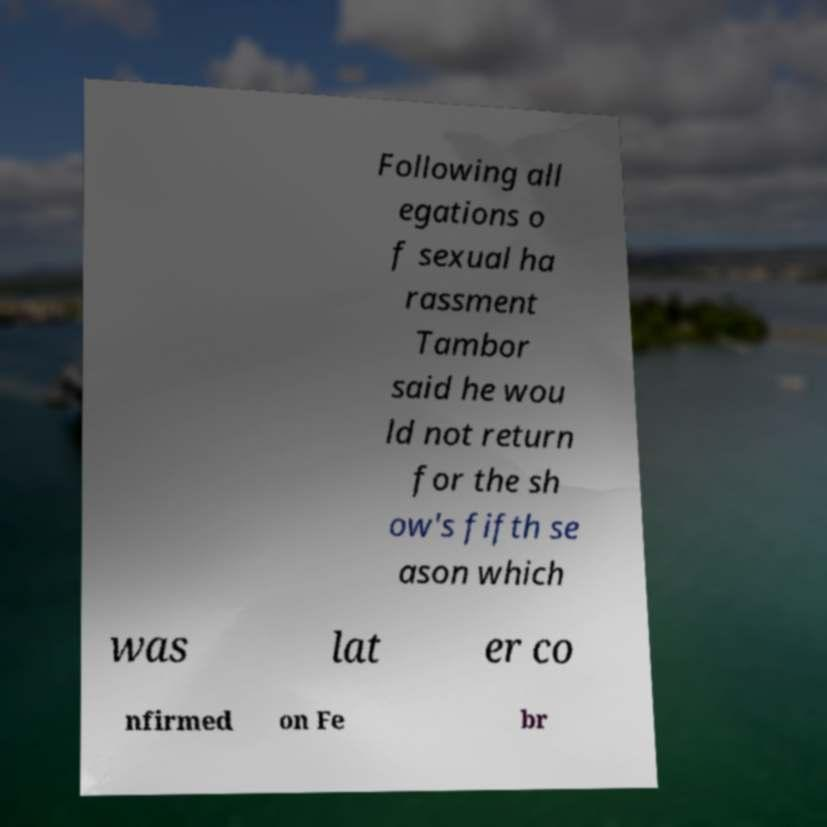Can you read and provide the text displayed in the image?This photo seems to have some interesting text. Can you extract and type it out for me? Following all egations o f sexual ha rassment Tambor said he wou ld not return for the sh ow's fifth se ason which was lat er co nfirmed on Fe br 